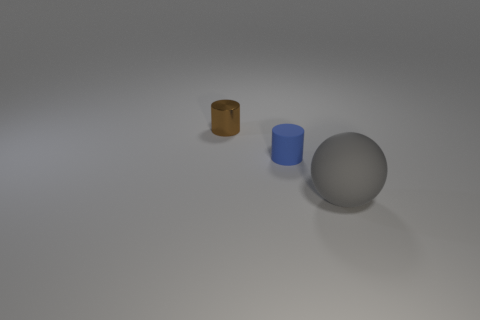Is there another thing that has the same shape as the big gray thing?
Keep it short and to the point. No. There is a blue rubber object that is the same size as the brown metallic thing; what shape is it?
Your answer should be very brief. Cylinder. Is the color of the ball the same as the matte thing that is on the left side of the matte ball?
Provide a succinct answer. No. How many tiny blue rubber cylinders are to the left of the rubber object that is behind the gray object?
Your answer should be very brief. 0. What is the size of the object that is on the right side of the brown metallic object and behind the large matte ball?
Give a very brief answer. Small. Is there a rubber thing that has the same size as the blue cylinder?
Provide a succinct answer. No. Is the number of big gray objects behind the gray ball greater than the number of small matte cylinders that are in front of the brown object?
Make the answer very short. No. Do the ball and the cylinder to the right of the small metal cylinder have the same material?
Your answer should be compact. Yes. How many blue matte cylinders are behind the small cylinder that is in front of the cylinder that is on the left side of the tiny blue cylinder?
Your answer should be compact. 0. There is a metallic thing; does it have the same shape as the matte object behind the gray matte thing?
Keep it short and to the point. Yes. 